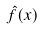Convert formula to latex. <formula><loc_0><loc_0><loc_500><loc_500>\hat { f } ( x )</formula> 